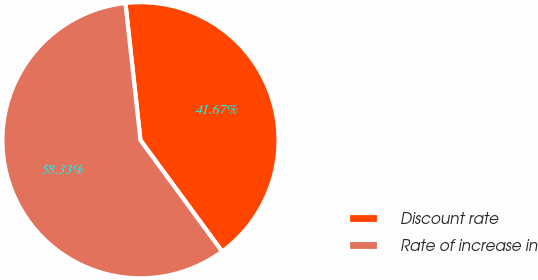Convert chart. <chart><loc_0><loc_0><loc_500><loc_500><pie_chart><fcel>Discount rate<fcel>Rate of increase in<nl><fcel>41.67%<fcel>58.33%<nl></chart> 